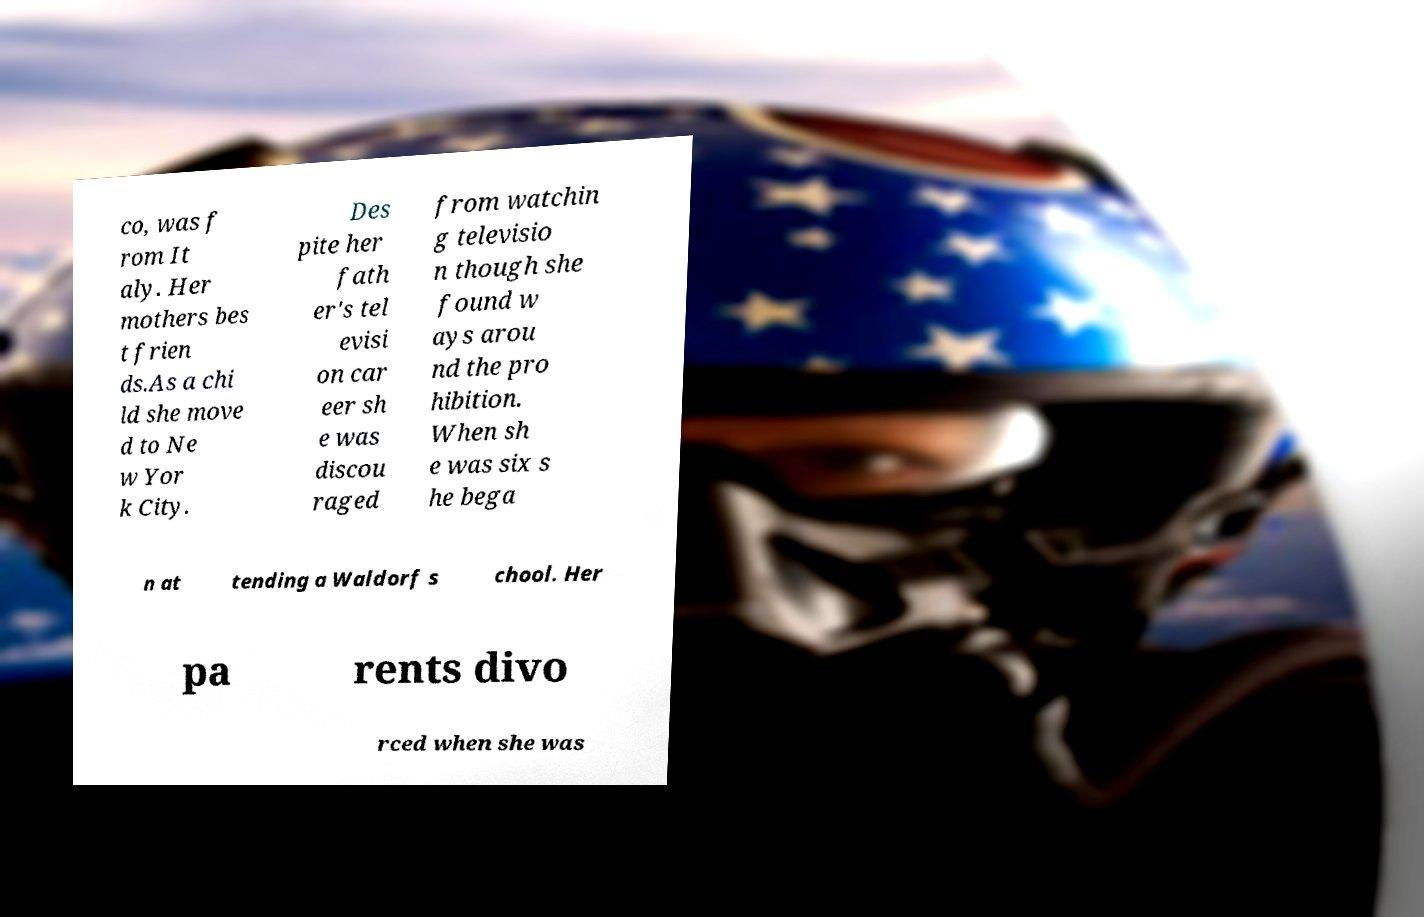Could you extract and type out the text from this image? co, was f rom It aly. Her mothers bes t frien ds.As a chi ld she move d to Ne w Yor k City. Des pite her fath er's tel evisi on car eer sh e was discou raged from watchin g televisio n though she found w ays arou nd the pro hibition. When sh e was six s he bega n at tending a Waldorf s chool. Her pa rents divo rced when she was 